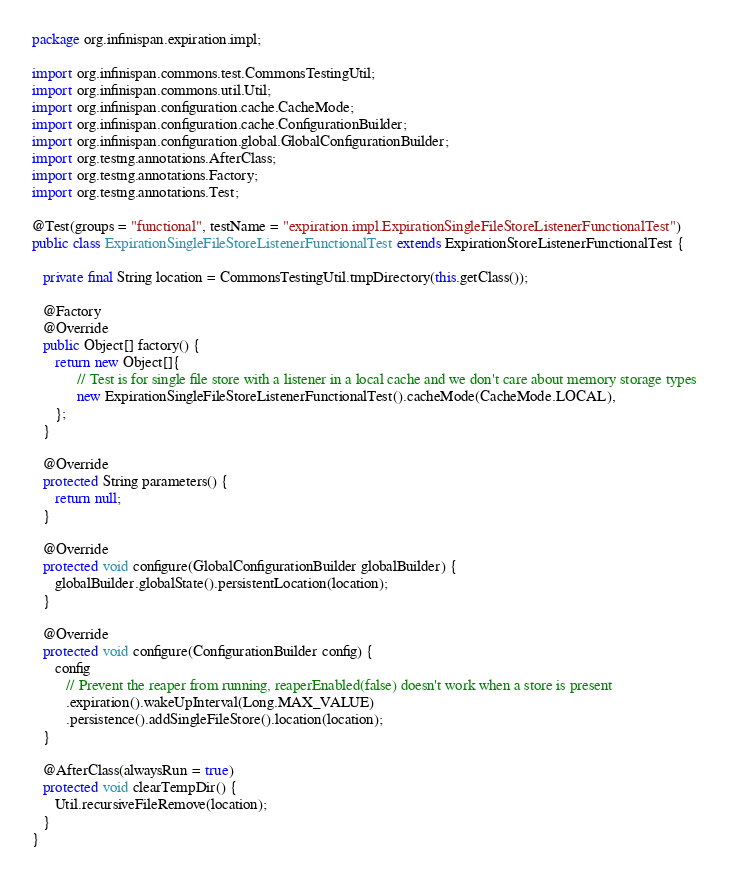Convert code to text. <code><loc_0><loc_0><loc_500><loc_500><_Java_>package org.infinispan.expiration.impl;

import org.infinispan.commons.test.CommonsTestingUtil;
import org.infinispan.commons.util.Util;
import org.infinispan.configuration.cache.CacheMode;
import org.infinispan.configuration.cache.ConfigurationBuilder;
import org.infinispan.configuration.global.GlobalConfigurationBuilder;
import org.testng.annotations.AfterClass;
import org.testng.annotations.Factory;
import org.testng.annotations.Test;

@Test(groups = "functional", testName = "expiration.impl.ExpirationSingleFileStoreListenerFunctionalTest")
public class ExpirationSingleFileStoreListenerFunctionalTest extends ExpirationStoreListenerFunctionalTest {

   private final String location = CommonsTestingUtil.tmpDirectory(this.getClass());

   @Factory
   @Override
   public Object[] factory() {
      return new Object[]{
            // Test is for single file store with a listener in a local cache and we don't care about memory storage types
            new ExpirationSingleFileStoreListenerFunctionalTest().cacheMode(CacheMode.LOCAL),
      };
   }

   @Override
   protected String parameters() {
      return null;
   }

   @Override
   protected void configure(GlobalConfigurationBuilder globalBuilder) {
      globalBuilder.globalState().persistentLocation(location);
   }

   @Override
   protected void configure(ConfigurationBuilder config) {
      config
         // Prevent the reaper from running, reaperEnabled(false) doesn't work when a store is present
         .expiration().wakeUpInterval(Long.MAX_VALUE)
         .persistence().addSingleFileStore().location(location);
   }

   @AfterClass(alwaysRun = true)
   protected void clearTempDir() {
      Util.recursiveFileRemove(location);
   }
}
</code> 